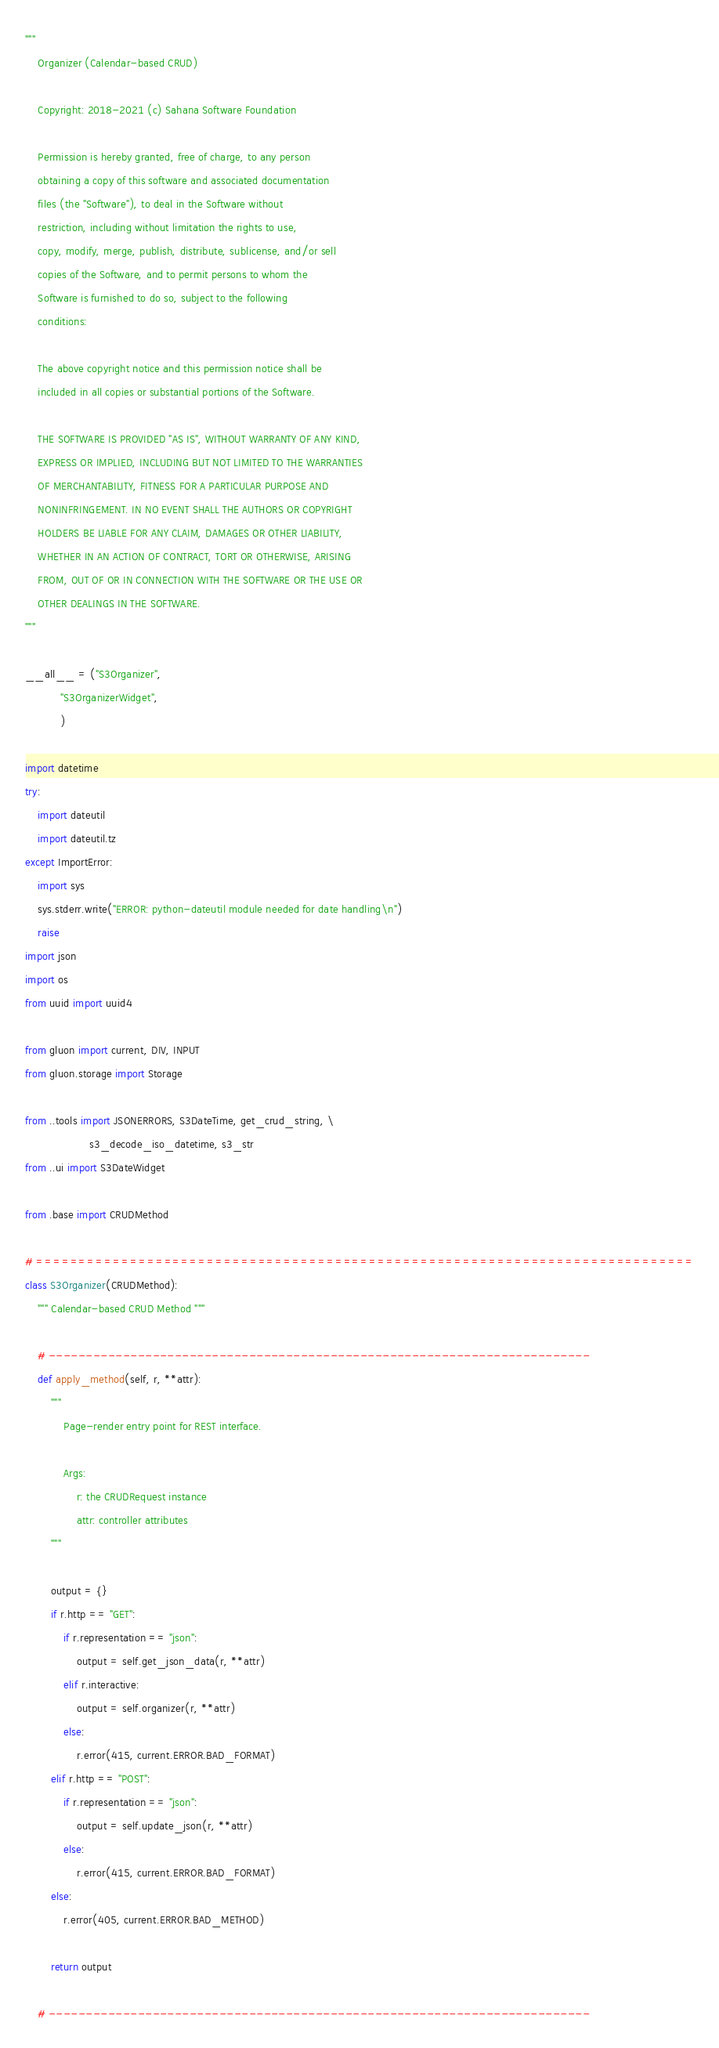Convert code to text. <code><loc_0><loc_0><loc_500><loc_500><_Python_>"""
    Organizer (Calendar-based CRUD)

    Copyright: 2018-2021 (c) Sahana Software Foundation

    Permission is hereby granted, free of charge, to any person
    obtaining a copy of this software and associated documentation
    files (the "Software"), to deal in the Software without
    restriction, including without limitation the rights to use,
    copy, modify, merge, publish, distribute, sublicense, and/or sell
    copies of the Software, and to permit persons to whom the
    Software is furnished to do so, subject to the following
    conditions:

    The above copyright notice and this permission notice shall be
    included in all copies or substantial portions of the Software.

    THE SOFTWARE IS PROVIDED "AS IS", WITHOUT WARRANTY OF ANY KIND,
    EXPRESS OR IMPLIED, INCLUDING BUT NOT LIMITED TO THE WARRANTIES
    OF MERCHANTABILITY, FITNESS FOR A PARTICULAR PURPOSE AND
    NONINFRINGEMENT. IN NO EVENT SHALL THE AUTHORS OR COPYRIGHT
    HOLDERS BE LIABLE FOR ANY CLAIM, DAMAGES OR OTHER LIABILITY,
    WHETHER IN AN ACTION OF CONTRACT, TORT OR OTHERWISE, ARISING
    FROM, OUT OF OR IN CONNECTION WITH THE SOFTWARE OR THE USE OR
    OTHER DEALINGS IN THE SOFTWARE.
"""

__all__ = ("S3Organizer",
           "S3OrganizerWidget",
           )

import datetime
try:
    import dateutil
    import dateutil.tz
except ImportError:
    import sys
    sys.stderr.write("ERROR: python-dateutil module needed for date handling\n")
    raise
import json
import os
from uuid import uuid4

from gluon import current, DIV, INPUT
from gluon.storage import Storage

from ..tools import JSONERRORS, S3DateTime, get_crud_string, \
                    s3_decode_iso_datetime, s3_str
from ..ui import S3DateWidget

from .base import CRUDMethod

# =============================================================================
class S3Organizer(CRUDMethod):
    """ Calendar-based CRUD Method """

    # -------------------------------------------------------------------------
    def apply_method(self, r, **attr):
        """
            Page-render entry point for REST interface.

            Args:
                r: the CRUDRequest instance
                attr: controller attributes
        """

        output = {}
        if r.http == "GET":
            if r.representation == "json":
                output = self.get_json_data(r, **attr)
            elif r.interactive:
                output = self.organizer(r, **attr)
            else:
                r.error(415, current.ERROR.BAD_FORMAT)
        elif r.http == "POST":
            if r.representation == "json":
                output = self.update_json(r, **attr)
            else:
                r.error(415, current.ERROR.BAD_FORMAT)
        else:
            r.error(405, current.ERROR.BAD_METHOD)

        return output

    # -------------------------------------------------------------------------</code> 